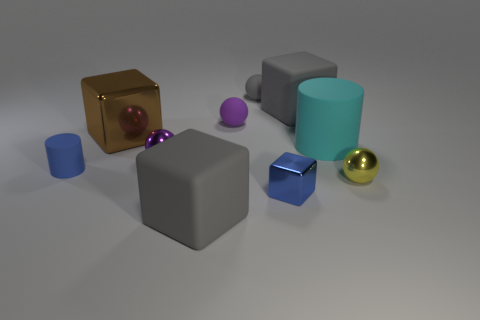Is the small shiny block the same color as the tiny rubber cylinder?
Offer a terse response. Yes. There is a big matte cube behind the tiny metallic ball that is in front of the blue cylinder; what color is it?
Ensure brevity in your answer.  Gray. There is a small purple object that is left of the large gray rubber block that is in front of the tiny blue object that is to the left of the gray ball; what is its material?
Your answer should be very brief. Metal. There is a metallic sphere to the left of the blue cube; is it the same size as the brown metal block?
Offer a terse response. No. What material is the blue thing that is behind the tiny block?
Keep it short and to the point. Rubber. Is the number of tiny gray rubber balls greater than the number of objects?
Your answer should be very brief. No. How many objects are large cubes on the right side of the gray rubber sphere or small blue rubber objects?
Provide a short and direct response. 2. There is a large rubber thing behind the big cylinder; what number of large brown things are to the right of it?
Provide a short and direct response. 0. What is the size of the metal block that is behind the yellow sphere that is in front of the matte cylinder that is on the right side of the purple matte sphere?
Offer a very short reply. Large. There is a metallic block in front of the cyan cylinder; does it have the same color as the tiny cylinder?
Keep it short and to the point. Yes. 